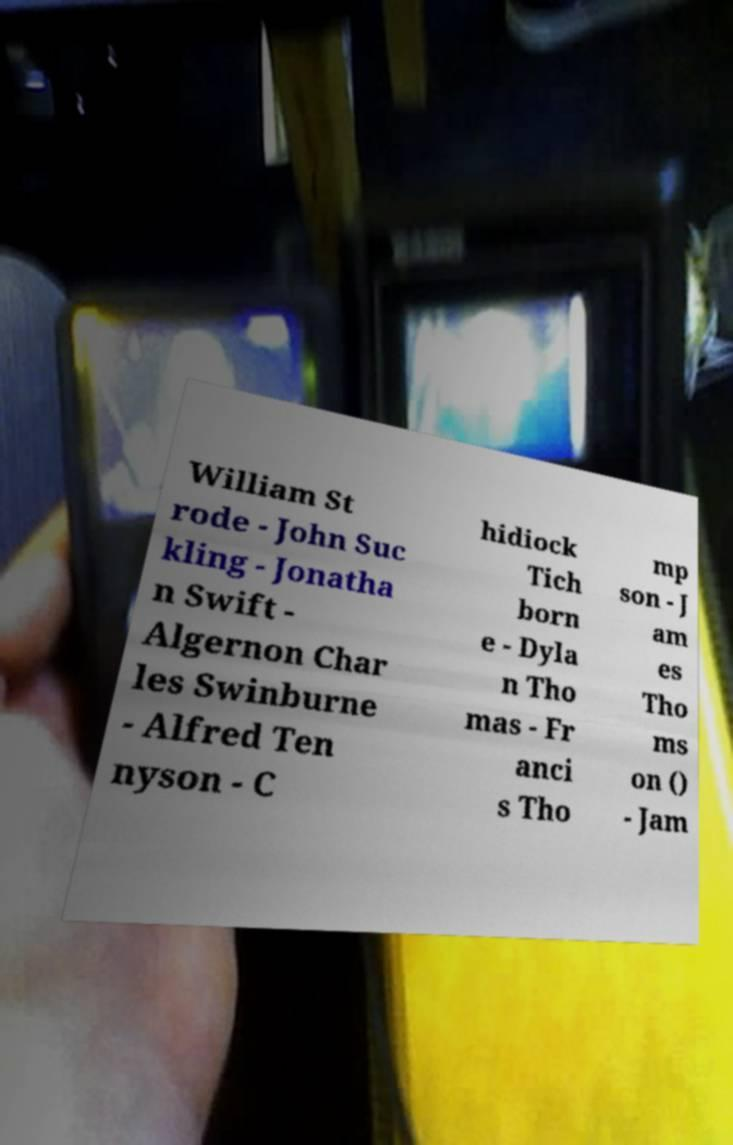There's text embedded in this image that I need extracted. Can you transcribe it verbatim? William St rode - John Suc kling - Jonatha n Swift - Algernon Char les Swinburne - Alfred Ten nyson - C hidiock Tich born e - Dyla n Tho mas - Fr anci s Tho mp son - J am es Tho ms on () - Jam 